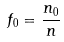<formula> <loc_0><loc_0><loc_500><loc_500>f _ { 0 } = \frac { n _ { 0 } } { n }</formula> 